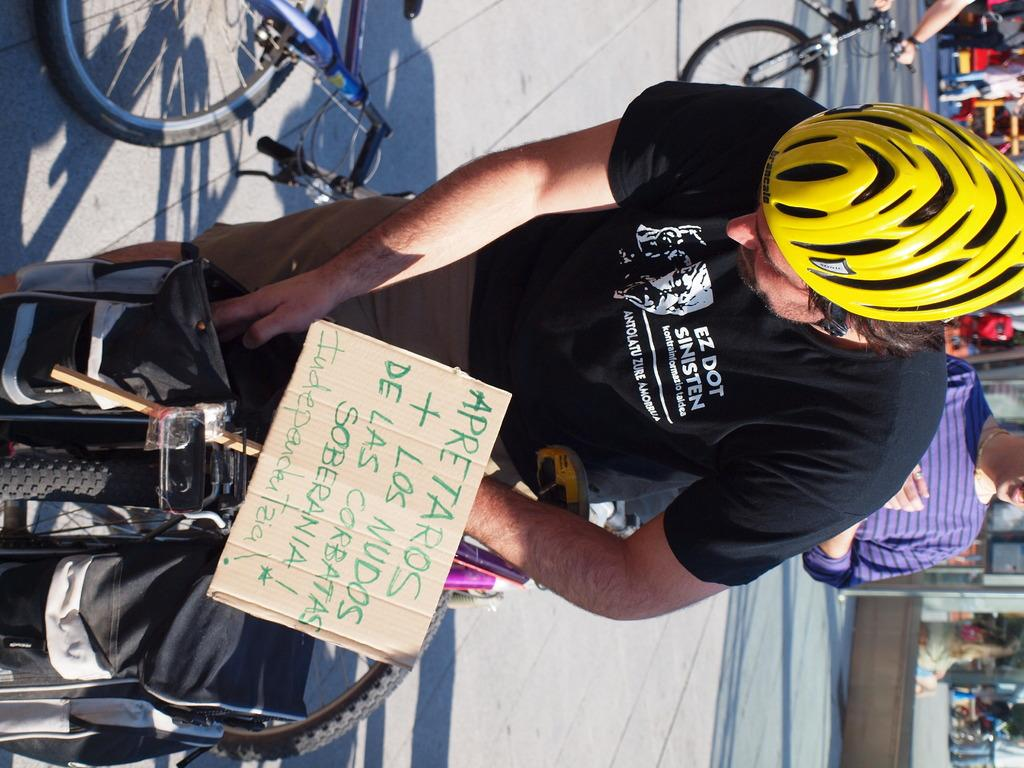Provide a one-sentence caption for the provided image. Person wearing a black shirt which says "EZ Dot" on it. 